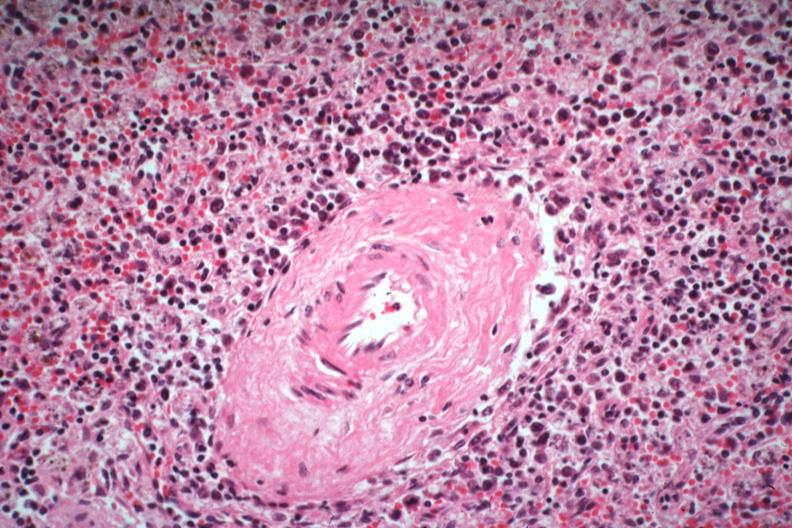what does this image show?
Answer the question using a single word or phrase. Atypical appearing immunoblastic cells near splenic arteriole man died of what was thought to be viral pneumonia probably influenza 